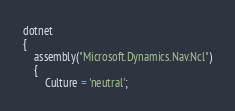<code> <loc_0><loc_0><loc_500><loc_500><_Perl_>dotnet
{
    assembly("Microsoft.Dynamics.Nav.Ncl")
    {
        Culture = 'neutral';</code> 